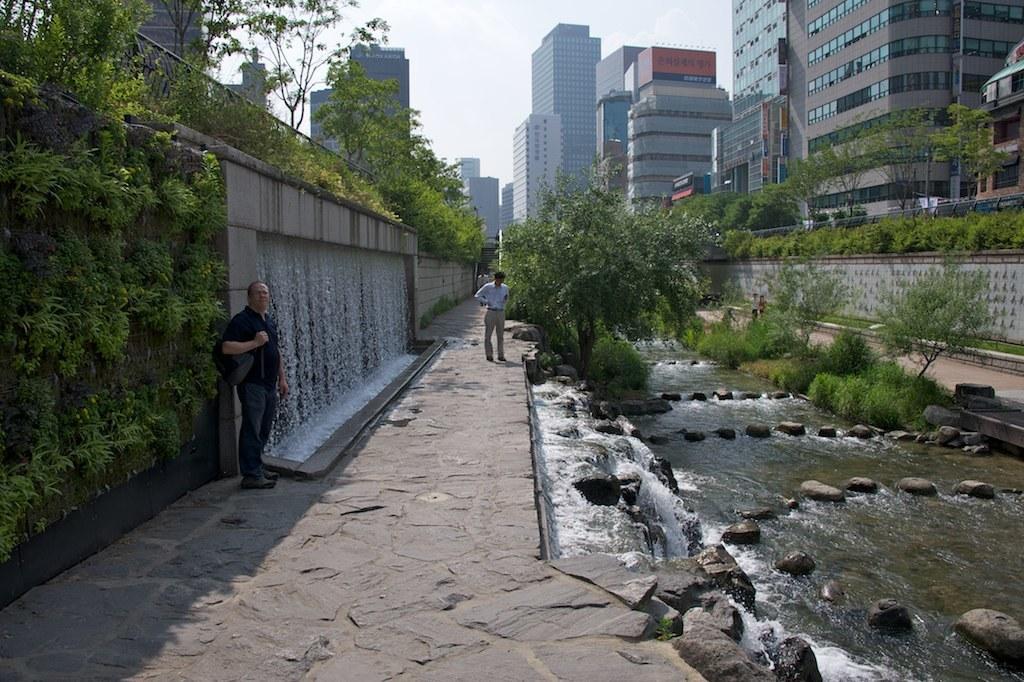Describe this image in one or two sentences. In this image few persons are standing on the stone path. Beside there are few stones having waterfall. There are few plants and trees. There are few stones on the land having water. Behind plants there are few persons on the path, beside there is a wall having few plants and fence on it. Left side there is a wall having plants and water falls. Top of wall there are few plants and fence. In background there are few buildings. Top of image there is sky. 